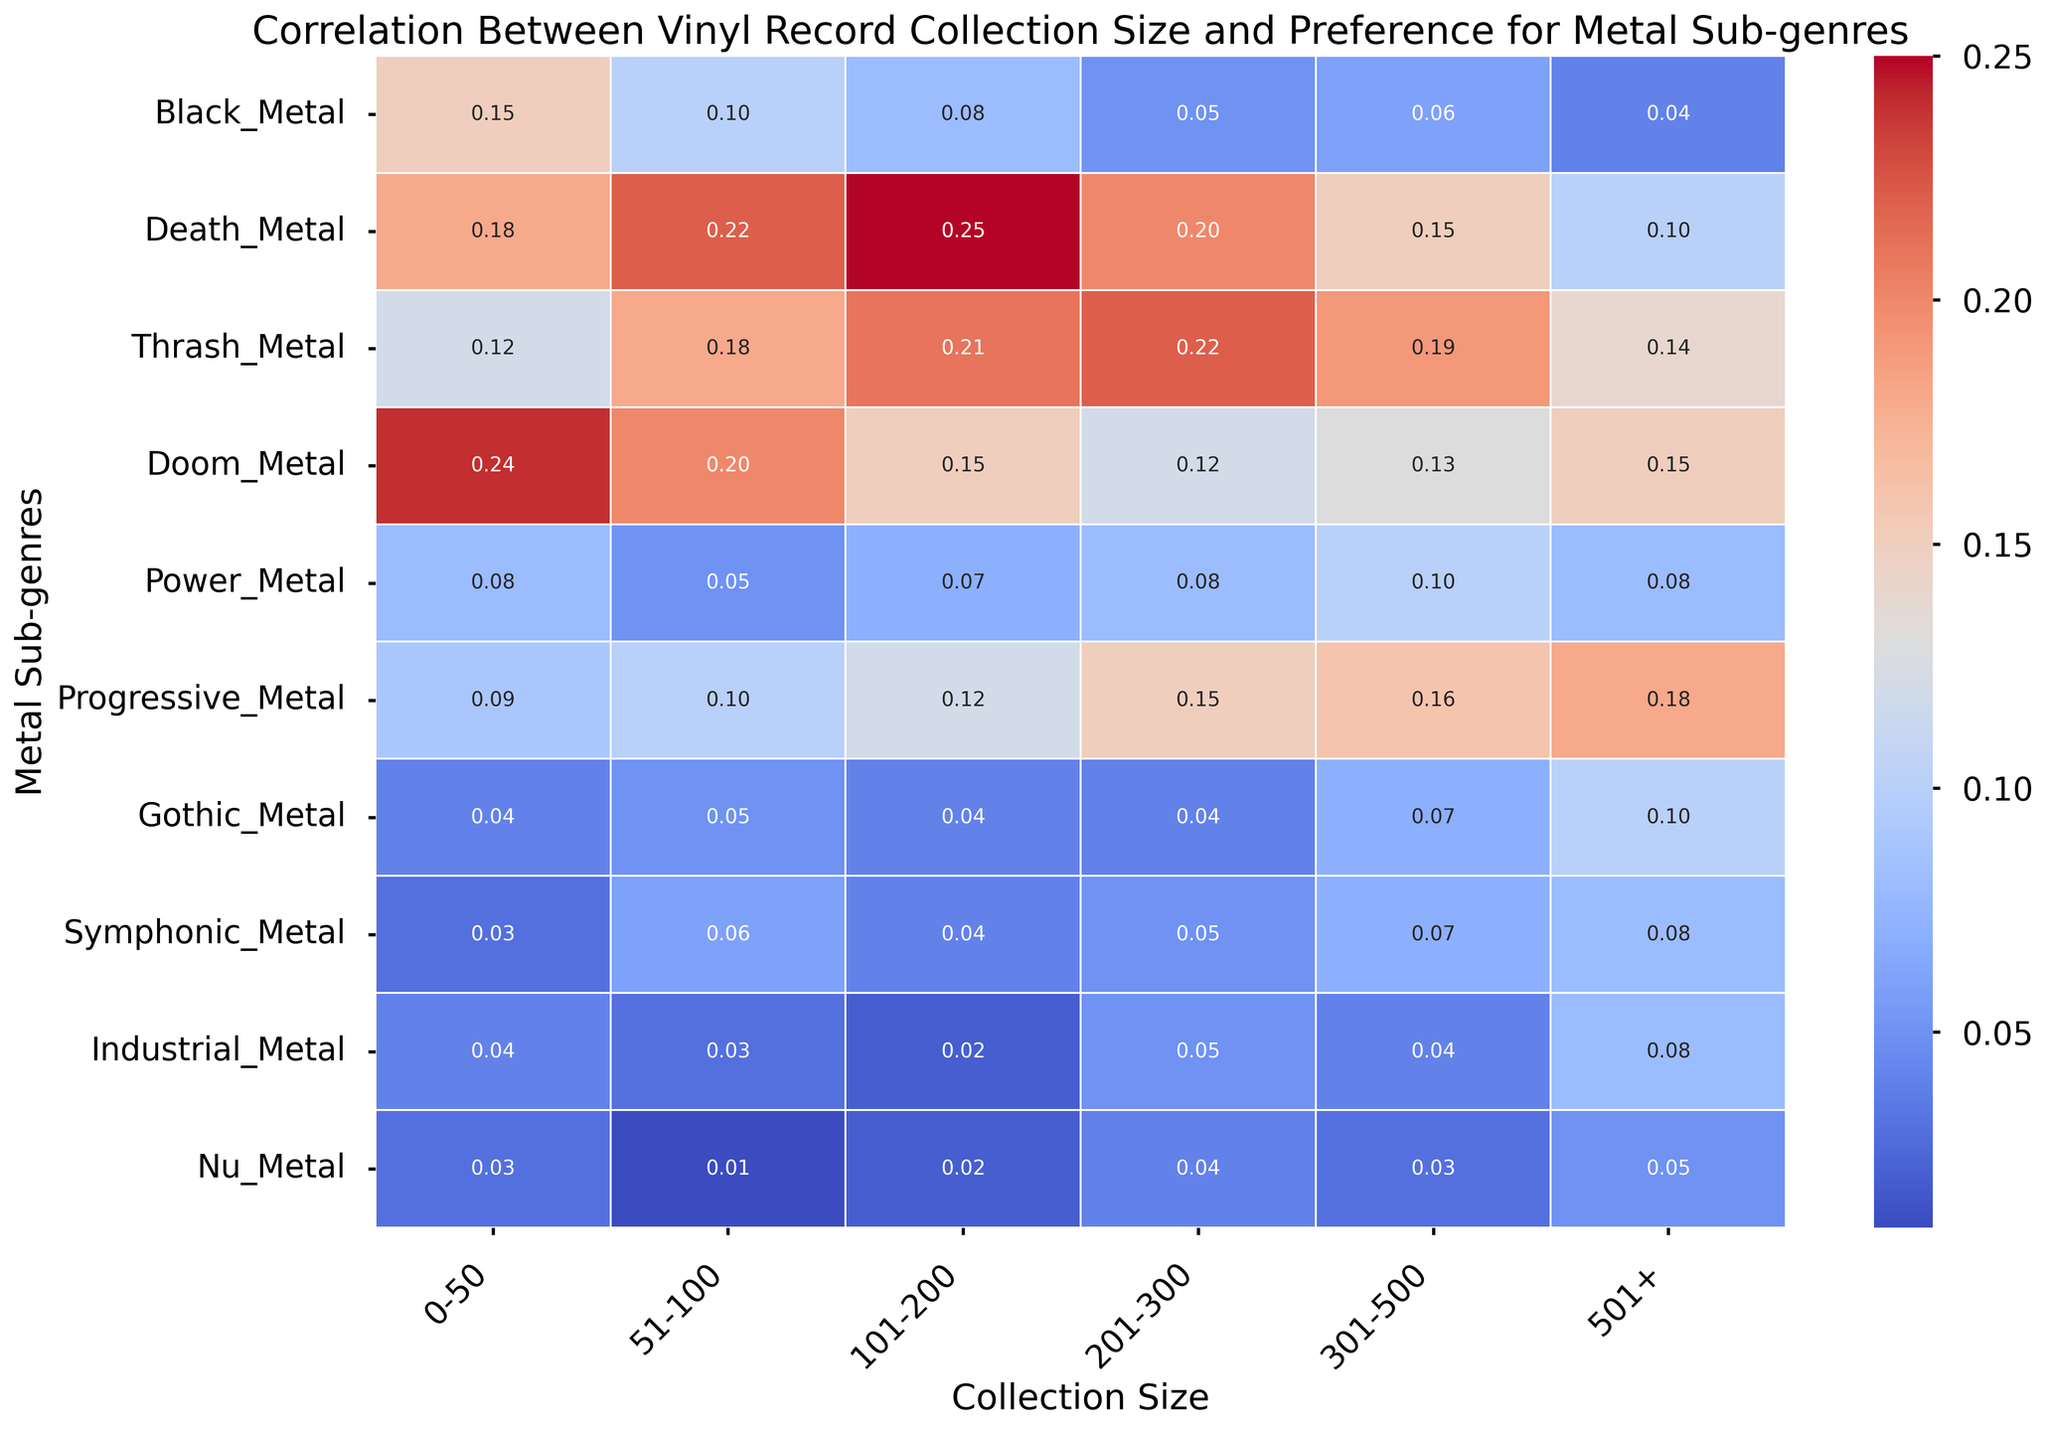What sub-genre of metal is most preferred by collectors with the smallest collection size (0-50 records)? Looking at the row representing the smallest collection size (0-50 records), the highest correlation value is for Doom Metal with 0.24.
Answer: Doom Metal How does the preference for Symphonic Metal change as the collection size increases? By observing the values in the Symphonic Metal row, we see that the values increase from 0.03 to 0.08 as the collection size grows from 0-50 to 501+.
Answer: Increases Which sub-genre has the sharpest decrease in preference as the collection size increases from 0-50 to 501+ records? To find the sharpest decrease, we calculate the difference for each sub-genre between collection sizes 0-50 and 501+. Black Metal decreases from 0.15 to 0.04, which is the steepest drop of 0.11.
Answer: Black Metal Between Death Metal and Power Metal, which has a more stable preference across different collection sizes? Comparing the values across all collection sizes for Death Metal and Power Metal, the fluctuations for Power Metal (0.08 to 0.10) are smaller than those for Death Metal (0.10 to 0.25).
Answer: Power Metal What is the average preference value for Progressive Metal across all collection sizes? The values for Progressive Metal are 0.09, 0.10, 0.12, 0.15, 0.16, and 0.18. Adding these together (0.09 + 0.10 + 0.12 + 0.15 + 0.16 + 0.18) gives 0.80. Dividing by 6 (number of data points) gives approximately 0.13.
Answer: 0.13 Which collection size group has the lowest preference for Nu Metal? Looking at the Nu Metal row, the smallest value is 0.01, which corresponds to the 51-100 collection size group.
Answer: 51-100 Is the correlation between collection size and preference for Industrial Metal more consistent or variable? The values for Industrial Metal are 0.04, 0.03, 0.02, 0.05, 0.04, and 0.08. These values are relatively consistent, with only minor deviations except for the last value.
Answer: Consistent What is the total sum of preferences for Gothic Metal across all collection sizes? The Gothic Metal preferences are 0.04, 0.05, 0.04, 0.04, 0.07, and 0.10. Summing these values gives 0.34.
Answer: 0.34 Which collection size group shows an equal preference for two or more sub-genres? Looking at the values, the collection size 0-50 shows an equal preference of 0.04 for Gothic Metal and Industrial Metal.
Answer: 0-50 Which sub-genre demonstrates the highest overall increase in preference from the smallest to the largest collection size? By comparing values from the smallest (0-50) to the largest (501+), Progressive Metal shows an increase from 0.09 to 0.18, which is the largest rise (0.09).
Answer: Progressive Metal 